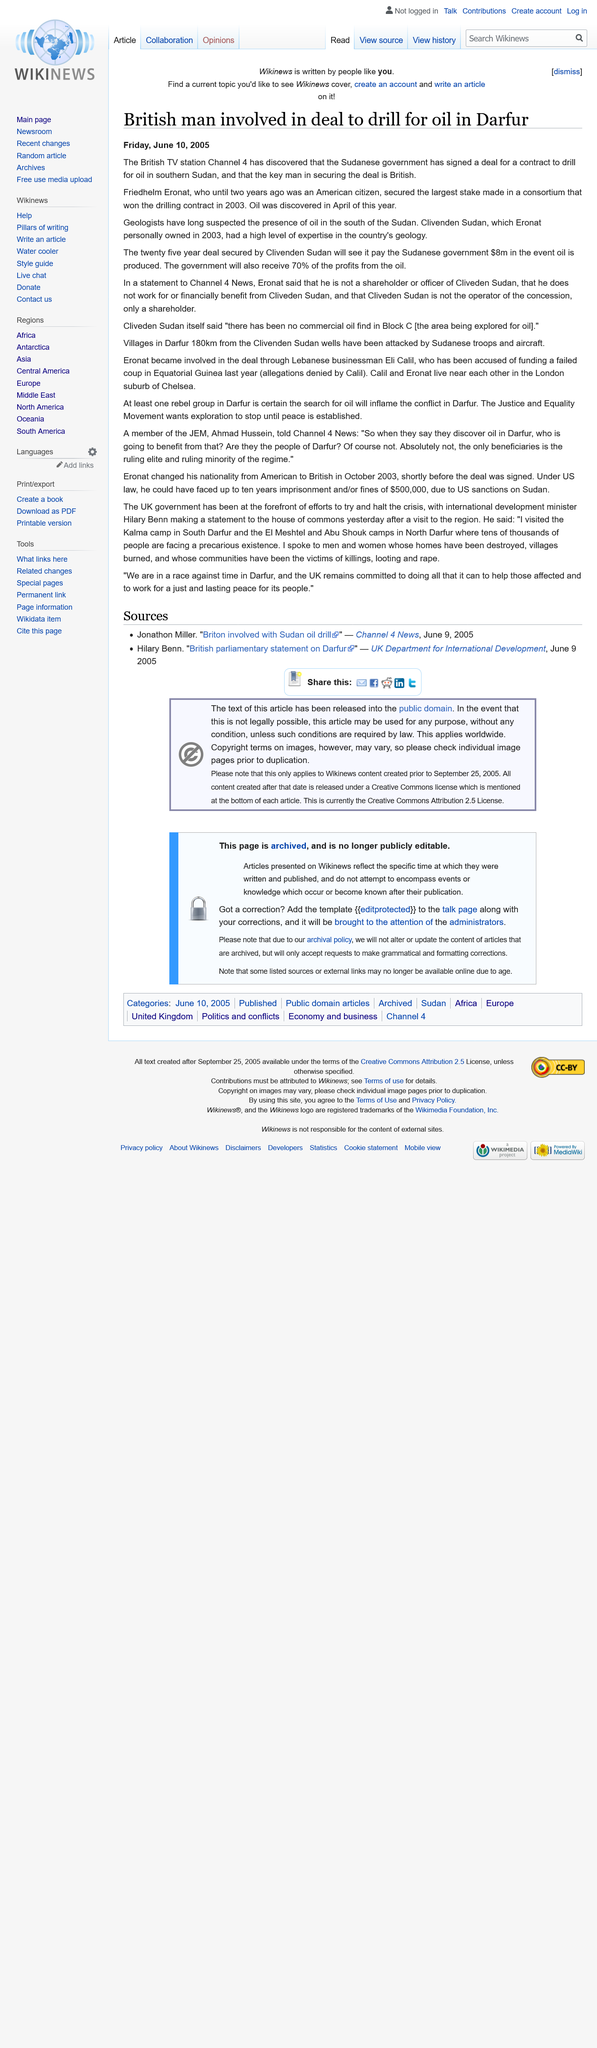Give some essential details in this illustration. The Sudanese government will receive 70% of the profits generated from oil production, as stated in the agreement. The agreement between Clivenden Sudan and the Sudanese government to extract oil for a period of twenty-five years has been declared. In 2003, Friedhelm Eronat was the owner of Clivenden Sudan. 